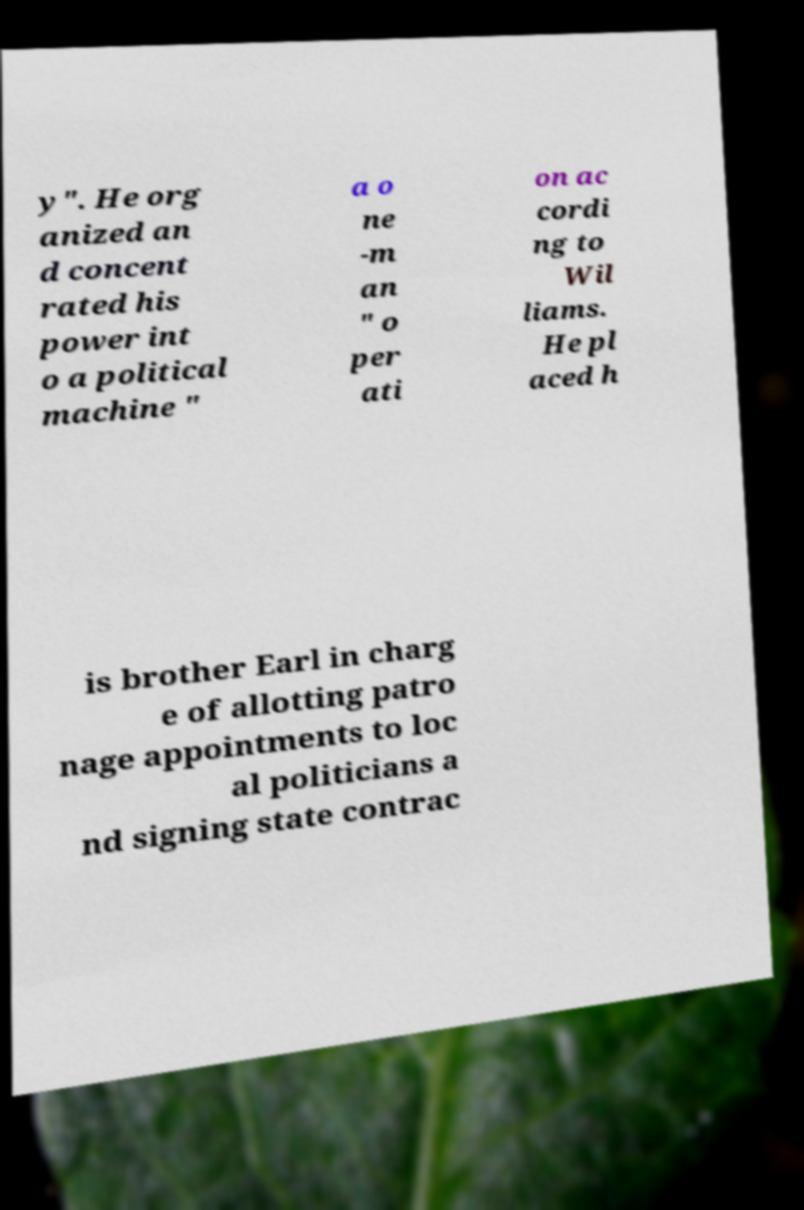I need the written content from this picture converted into text. Can you do that? y". He org anized an d concent rated his power int o a political machine " a o ne -m an " o per ati on ac cordi ng to Wil liams. He pl aced h is brother Earl in charg e of allotting patro nage appointments to loc al politicians a nd signing state contrac 